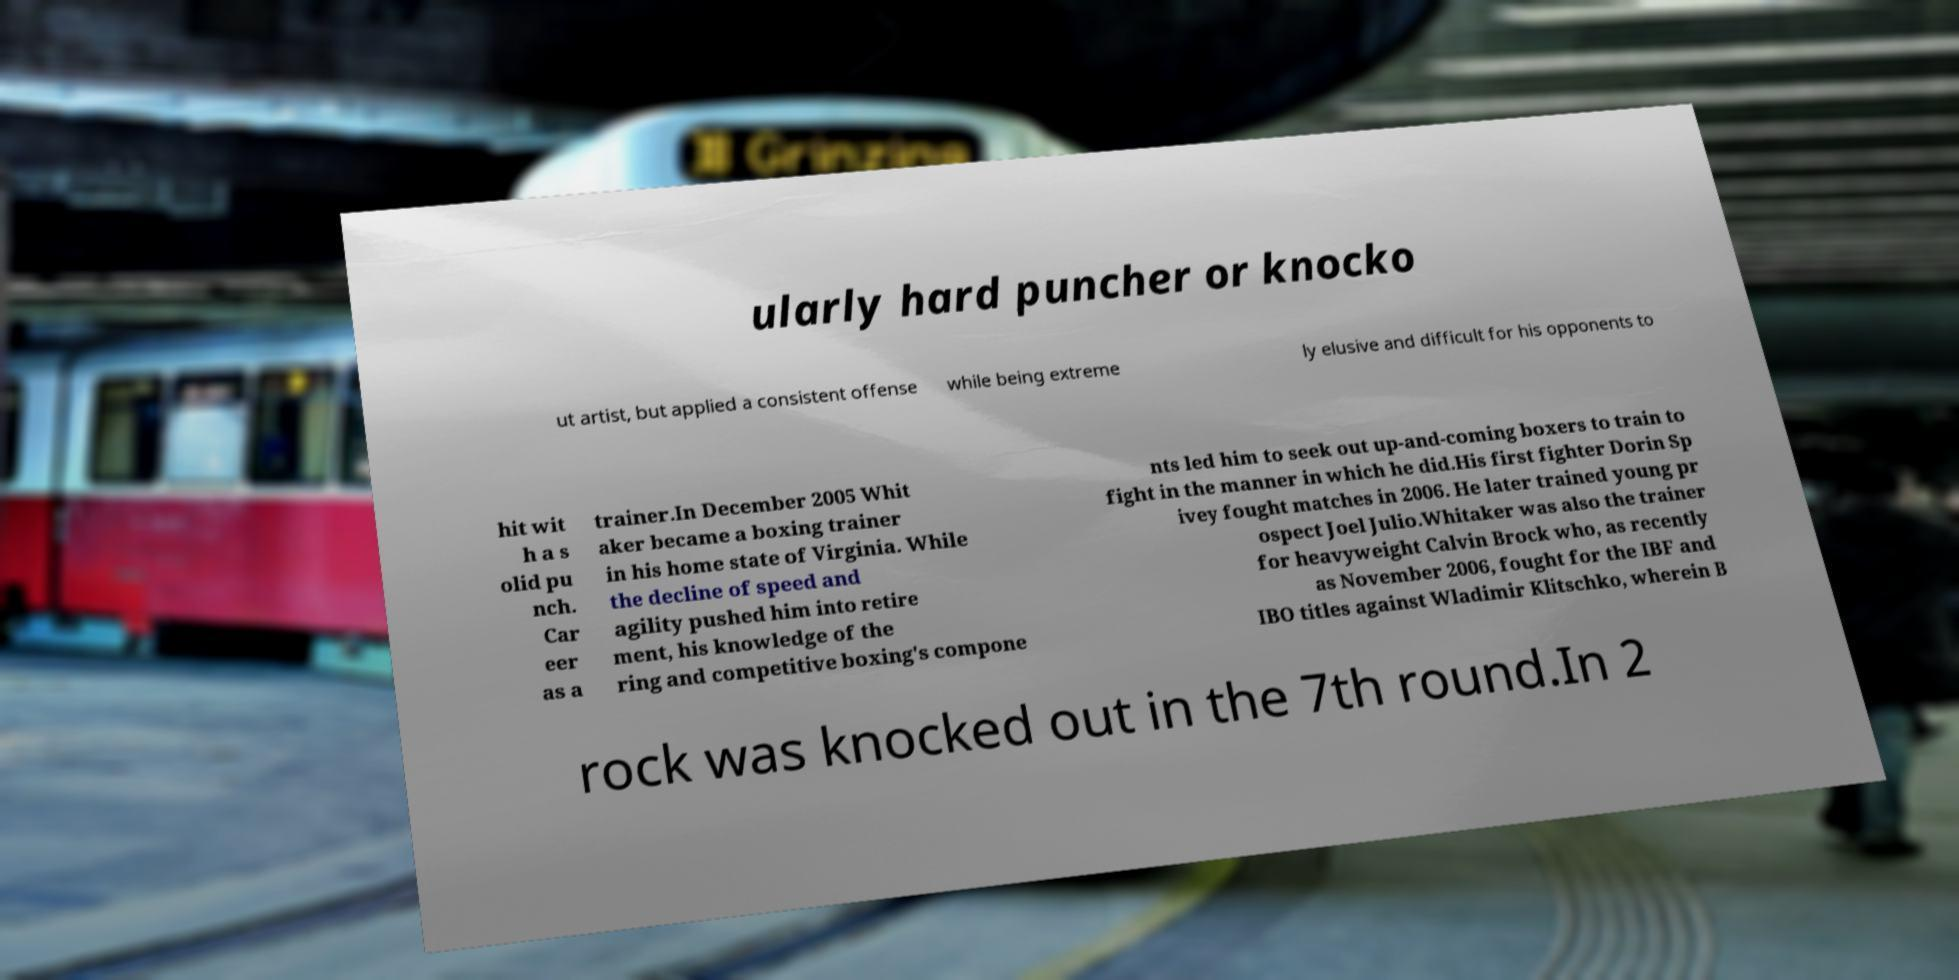For documentation purposes, I need the text within this image transcribed. Could you provide that? ularly hard puncher or knocko ut artist, but applied a consistent offense while being extreme ly elusive and difficult for his opponents to hit wit h a s olid pu nch. Car eer as a trainer.In December 2005 Whit aker became a boxing trainer in his home state of Virginia. While the decline of speed and agility pushed him into retire ment, his knowledge of the ring and competitive boxing's compone nts led him to seek out up-and-coming boxers to train to fight in the manner in which he did.His first fighter Dorin Sp ivey fought matches in 2006. He later trained young pr ospect Joel Julio.Whitaker was also the trainer for heavyweight Calvin Brock who, as recently as November 2006, fought for the IBF and IBO titles against Wladimir Klitschko, wherein B rock was knocked out in the 7th round.In 2 